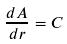<formula> <loc_0><loc_0><loc_500><loc_500>\frac { d A } { d r } = C</formula> 